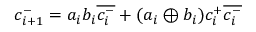<formula> <loc_0><loc_0><loc_500><loc_500>c _ { i + 1 } ^ { - } = a _ { i } b _ { i } { \overline { { c _ { i } ^ { - } } } } + ( a _ { i } \oplus b _ { i } ) c _ { i } ^ { + } { \overline { { c _ { i } ^ { - } } } }</formula> 